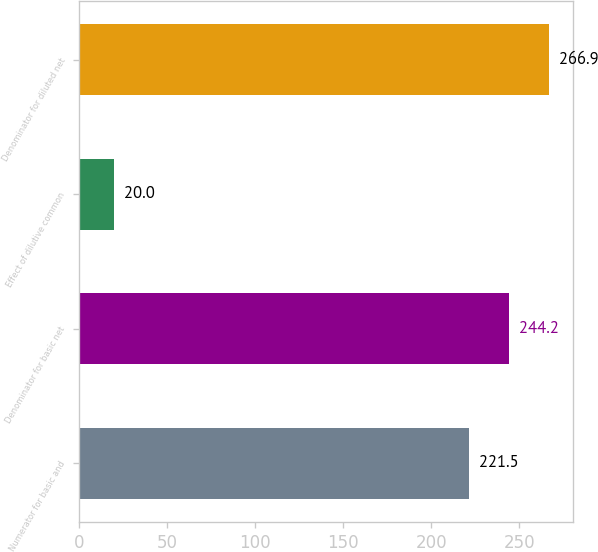Convert chart to OTSL. <chart><loc_0><loc_0><loc_500><loc_500><bar_chart><fcel>Numerator for basic and<fcel>Denominator for basic net<fcel>Effect of dilutive common<fcel>Denominator for diluted net<nl><fcel>221.5<fcel>244.2<fcel>20<fcel>266.9<nl></chart> 